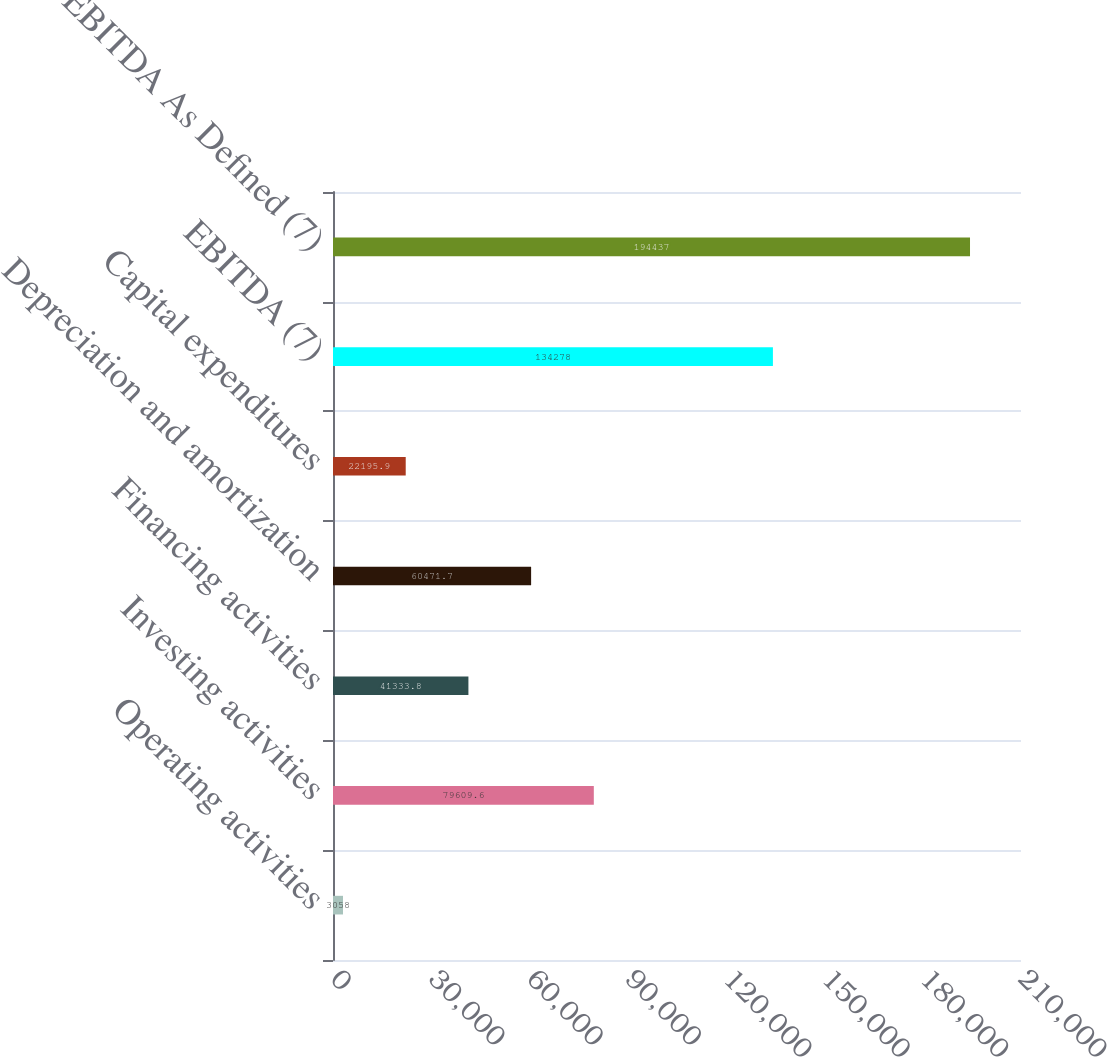<chart> <loc_0><loc_0><loc_500><loc_500><bar_chart><fcel>Operating activities<fcel>Investing activities<fcel>Financing activities<fcel>Depreciation and amortization<fcel>Capital expenditures<fcel>EBITDA (7)<fcel>EBITDA As Defined (7)<nl><fcel>3058<fcel>79609.6<fcel>41333.8<fcel>60471.7<fcel>22195.9<fcel>134278<fcel>194437<nl></chart> 